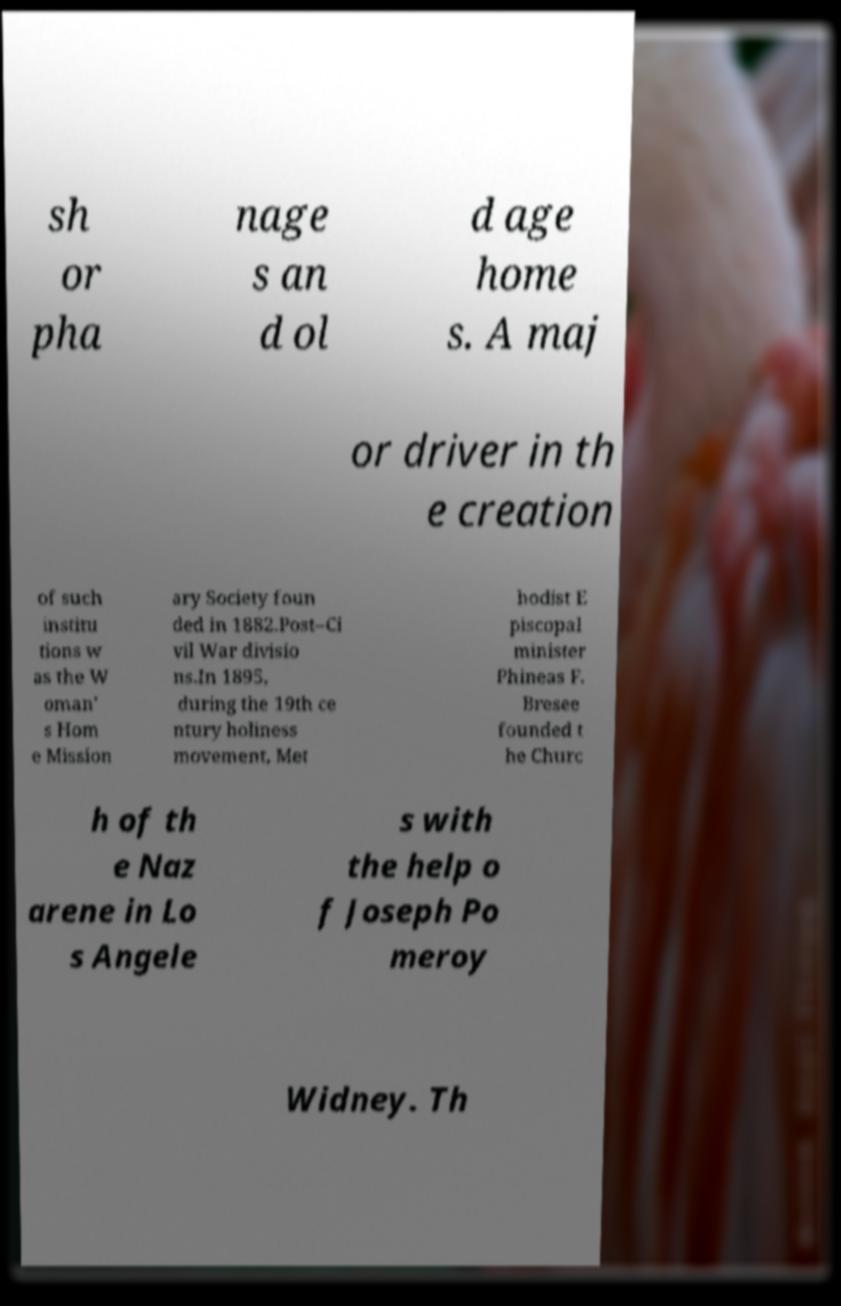Please read and relay the text visible in this image. What does it say? sh or pha nage s an d ol d age home s. A maj or driver in th e creation of such institu tions w as the W oman' s Hom e Mission ary Society foun ded in 1882.Post–Ci vil War divisio ns.In 1895, during the 19th ce ntury holiness movement, Met hodist E piscopal minister Phineas F. Bresee founded t he Churc h of th e Naz arene in Lo s Angele s with the help o f Joseph Po meroy Widney. Th 